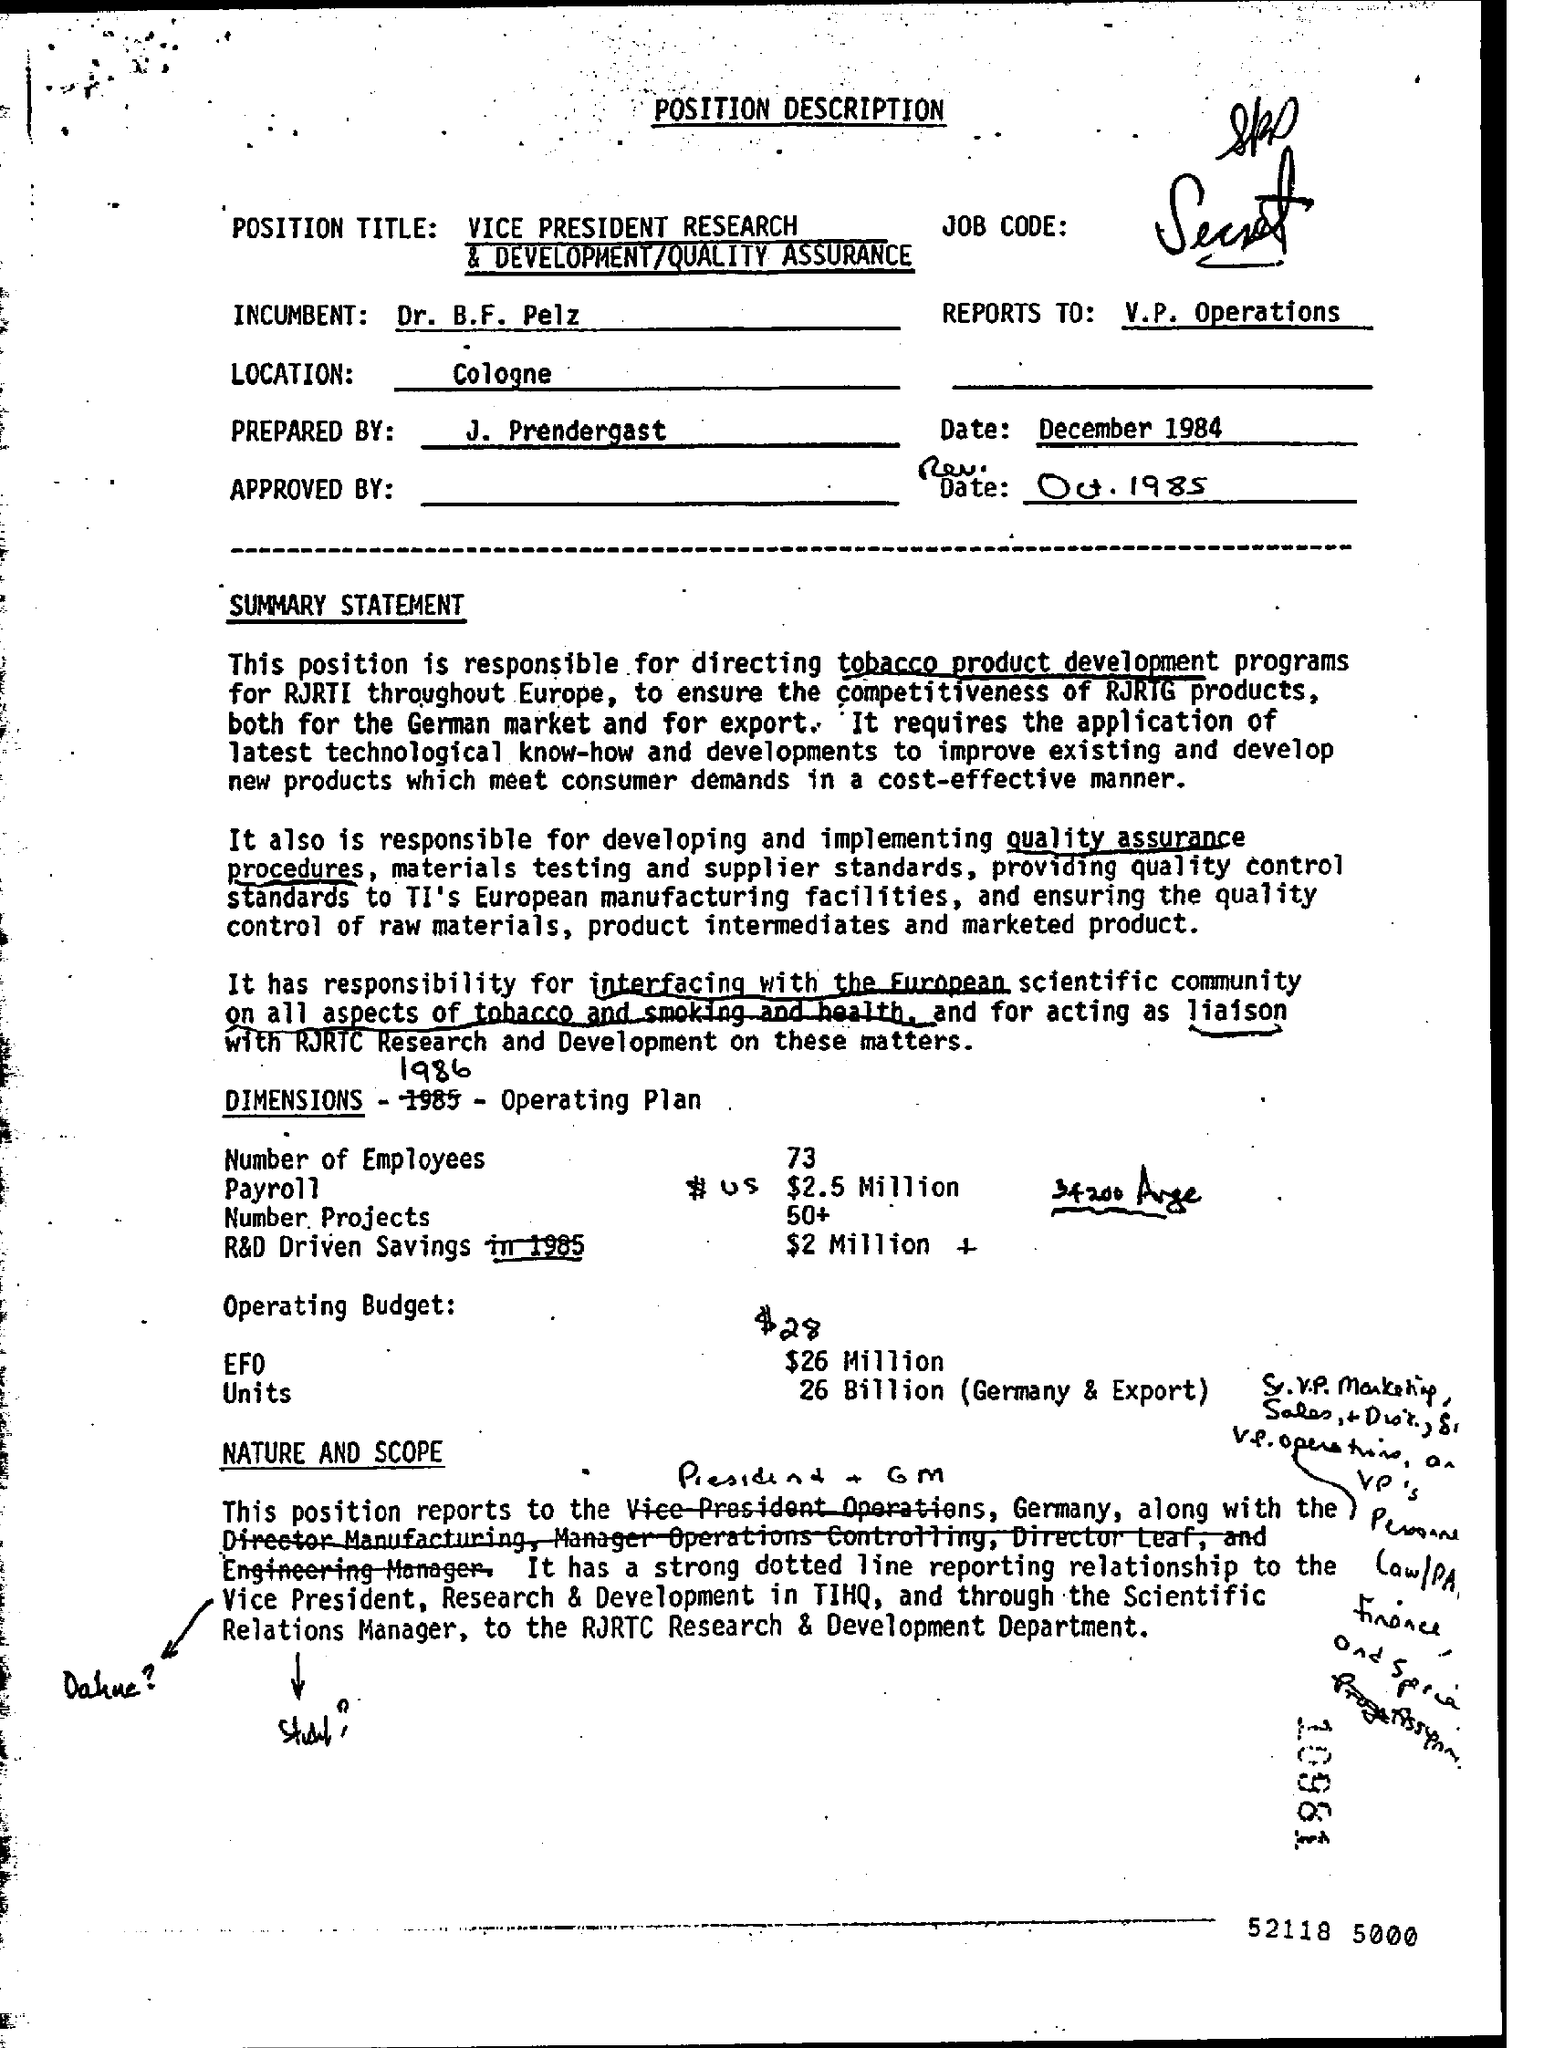What is written in the Letter Head ?
Your answer should be compact. POSITION DESCRIPTION. What is the date mentioned in the top of the document ?
Your answer should be compact. December 1984. Who is prepared this ?
Provide a short and direct response. J. Prendergast. Where is the Location ?
Ensure brevity in your answer.  Cologne. 